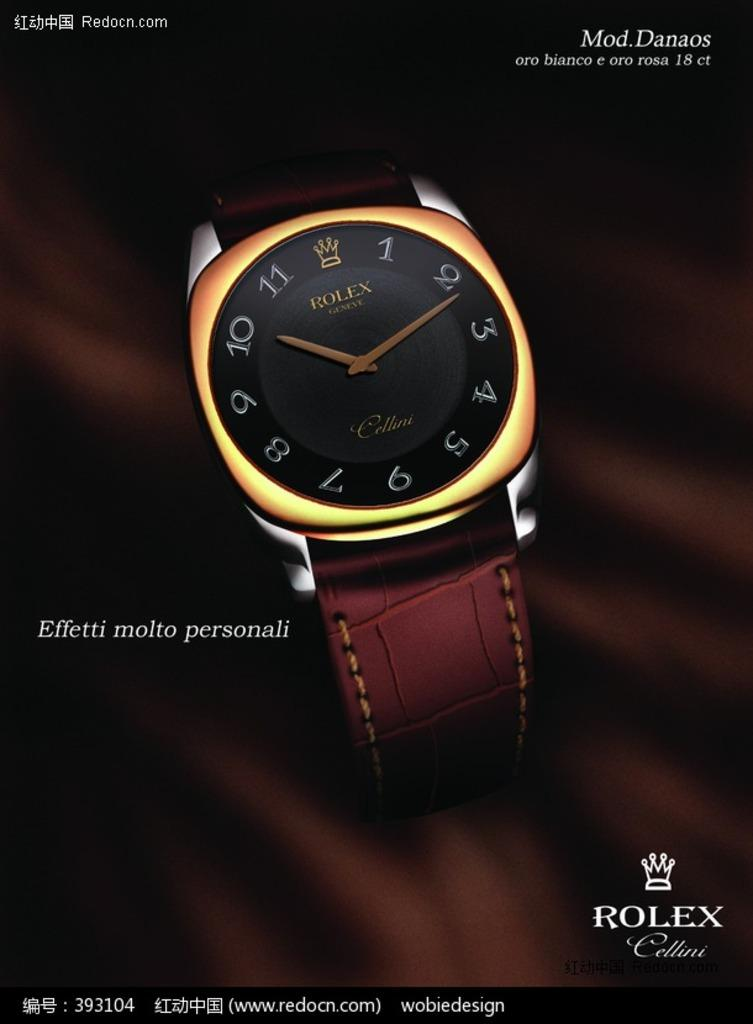<image>
Describe the image concisely. Rolex watch that is gold and tells the time 